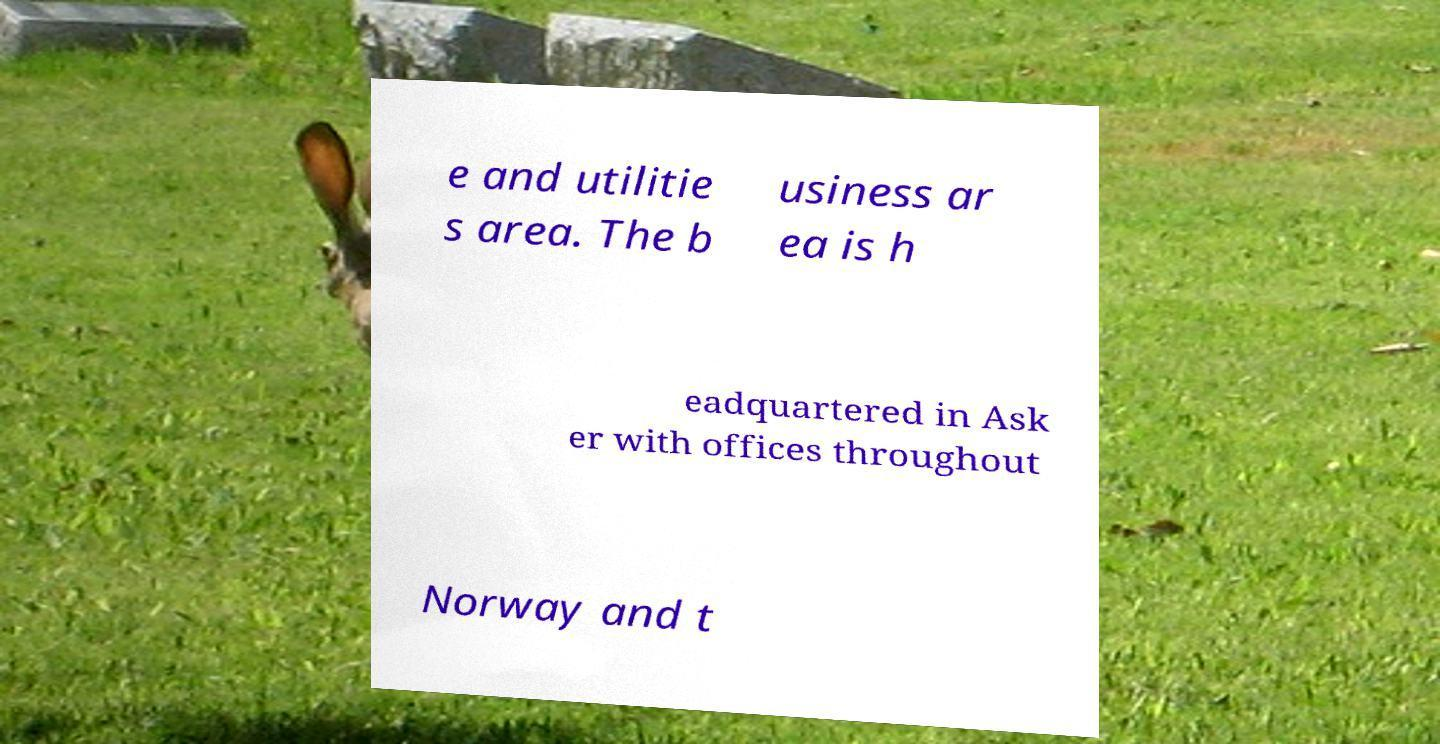I need the written content from this picture converted into text. Can you do that? e and utilitie s area. The b usiness ar ea is h eadquartered in Ask er with offices throughout Norway and t 